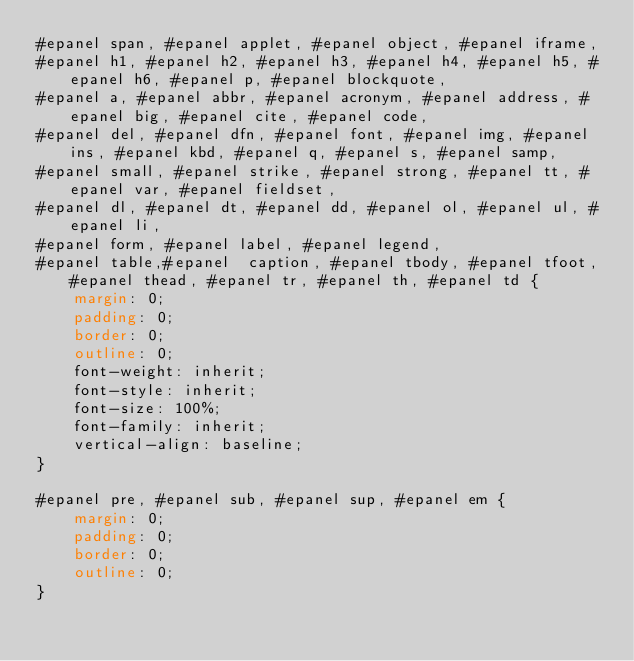<code> <loc_0><loc_0><loc_500><loc_500><_CSS_>#epanel span, #epanel applet, #epanel object, #epanel iframe,
#epanel h1, #epanel h2, #epanel h3, #epanel h4, #epanel h5, #epanel h6, #epanel p, #epanel blockquote,
#epanel a, #epanel abbr, #epanel acronym, #epanel address, #epanel big, #epanel cite, #epanel code,
#epanel del, #epanel dfn, #epanel font, #epanel img, #epanel ins, #epanel kbd, #epanel q, #epanel s, #epanel samp,
#epanel small, #epanel strike, #epanel strong, #epanel tt, #epanel var, #epanel fieldset,
#epanel dl, #epanel dt, #epanel dd, #epanel ol, #epanel ul, #epanel li,
#epanel form, #epanel label, #epanel legend,
#epanel table,#epanel  caption, #epanel tbody, #epanel tfoot, #epanel thead, #epanel tr, #epanel th, #epanel td {
	margin: 0;
	padding: 0;
	border: 0;
	outline: 0;
	font-weight: inherit;
	font-style: inherit;
	font-size: 100%;
	font-family: inherit;
	vertical-align: baseline;
}

#epanel pre, #epanel sub, #epanel sup, #epanel em {
	margin: 0;
	padding: 0;
	border: 0;
	outline: 0;
}
</code> 